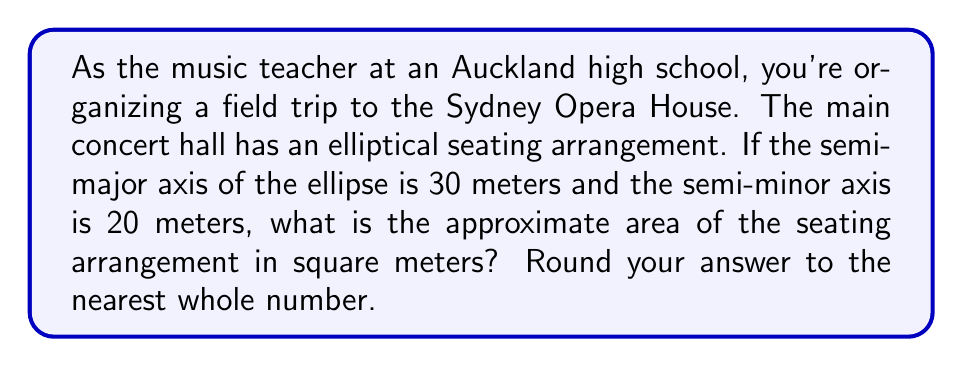Help me with this question. To find the area of an elliptical seating arrangement, we need to use the formula for the area of an ellipse:

$$A = \pi ab$$

Where:
$A$ = area of the ellipse
$a$ = length of the semi-major axis
$b$ = length of the semi-minor axis
$\pi$ ≈ 3.14159

Given:
$a = 30$ meters
$b = 20$ meters

Let's substitute these values into the formula:

$$A = \pi (30)(20)$$

Now, let's calculate:

$$\begin{align*}
A &= 3.14159 \times 30 \times 20 \\
&= 3.14159 \times 600 \\
&= 1884.954 \text{ square meters}
\end{align*}$$

Rounding to the nearest whole number:

$$A \approx 1885 \text{ square meters}$$

[asy]
unitsize(4mm);
draw(ellipse((0,0),30,20), linewidth(0.7));
draw((-30,0)--(30,0), arrow=Arrow(TeXHead));
draw((0,-20)--(0,20), arrow=Arrow(TeXHead));
label("30m", (15,-2), S);
label("20m", (2,10), E);
[/asy]
Answer: 1885 square meters 